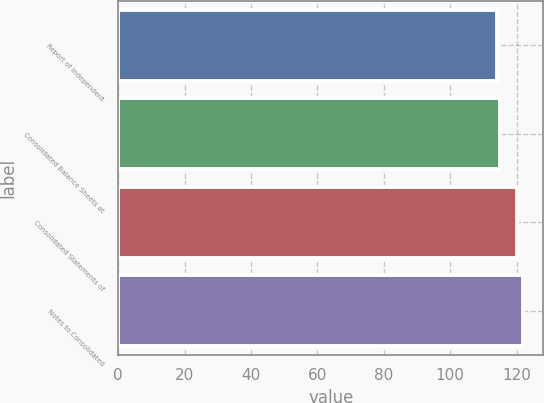<chart> <loc_0><loc_0><loc_500><loc_500><bar_chart><fcel>Report of Independent<fcel>Consolidated Balance Sheets at<fcel>Consolidated Statements of<fcel>Notes to Consolidated<nl><fcel>114<fcel>115<fcel>120<fcel>122<nl></chart> 